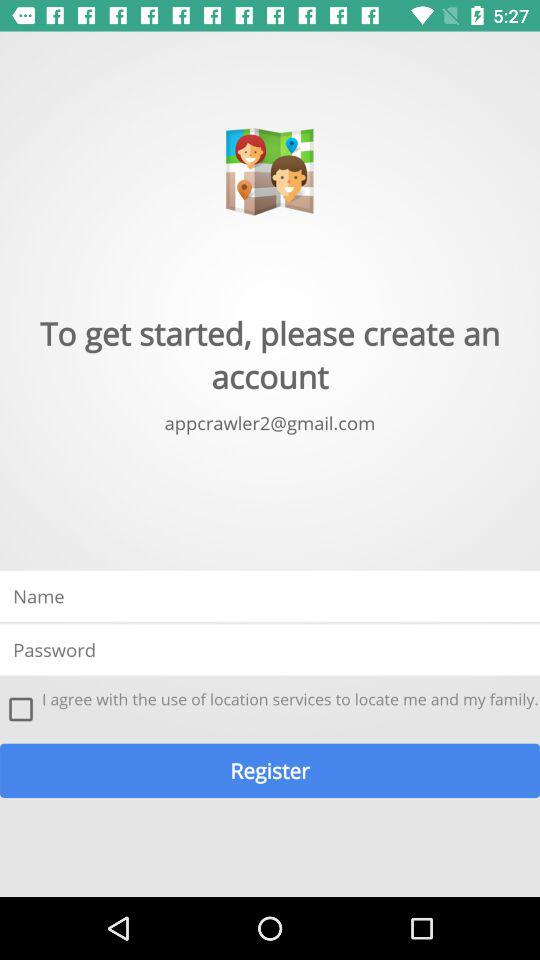Where is the user located?
When the provided information is insufficient, respond with <no answer>. <no answer> 